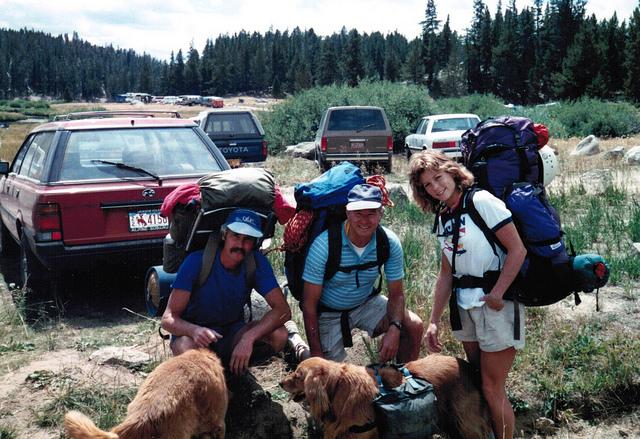What are the people carrying?
Write a very short answer. Backpacks. What kind of animals are in the picture?
Keep it brief. Dogs. Where are they going to camp at?
Be succinct. Woods. 